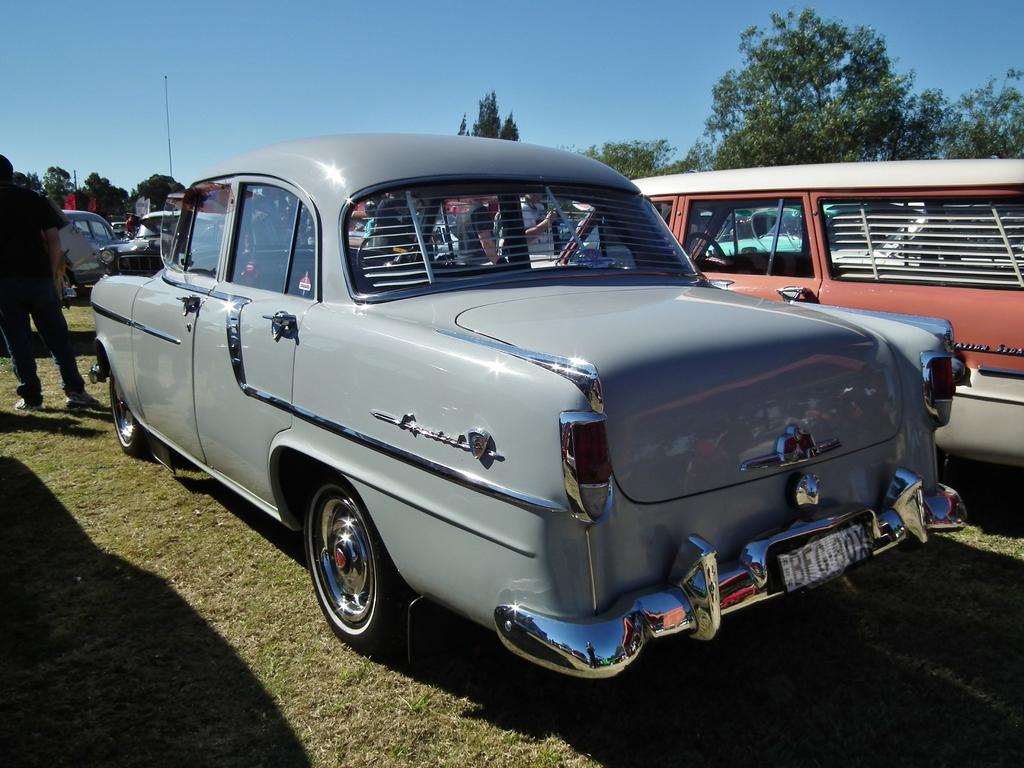What type of surface are the cars placed on in the image? The cars are on the grass floor in the image. Can you describe the people in the image? There are people in the image, but their specific characteristics are not mentioned in the facts. What type of natural elements can be seen in the image? There are trees in the image. What is the pole used for in the image? The purpose of the pole in the image is not mentioned in the facts. Is there a baby being held by a grandmother under an umbrella in the image? There is no mention of a baby, a grandmother, or an umbrella in the provided facts, so we cannot confirm their presence in the image. 